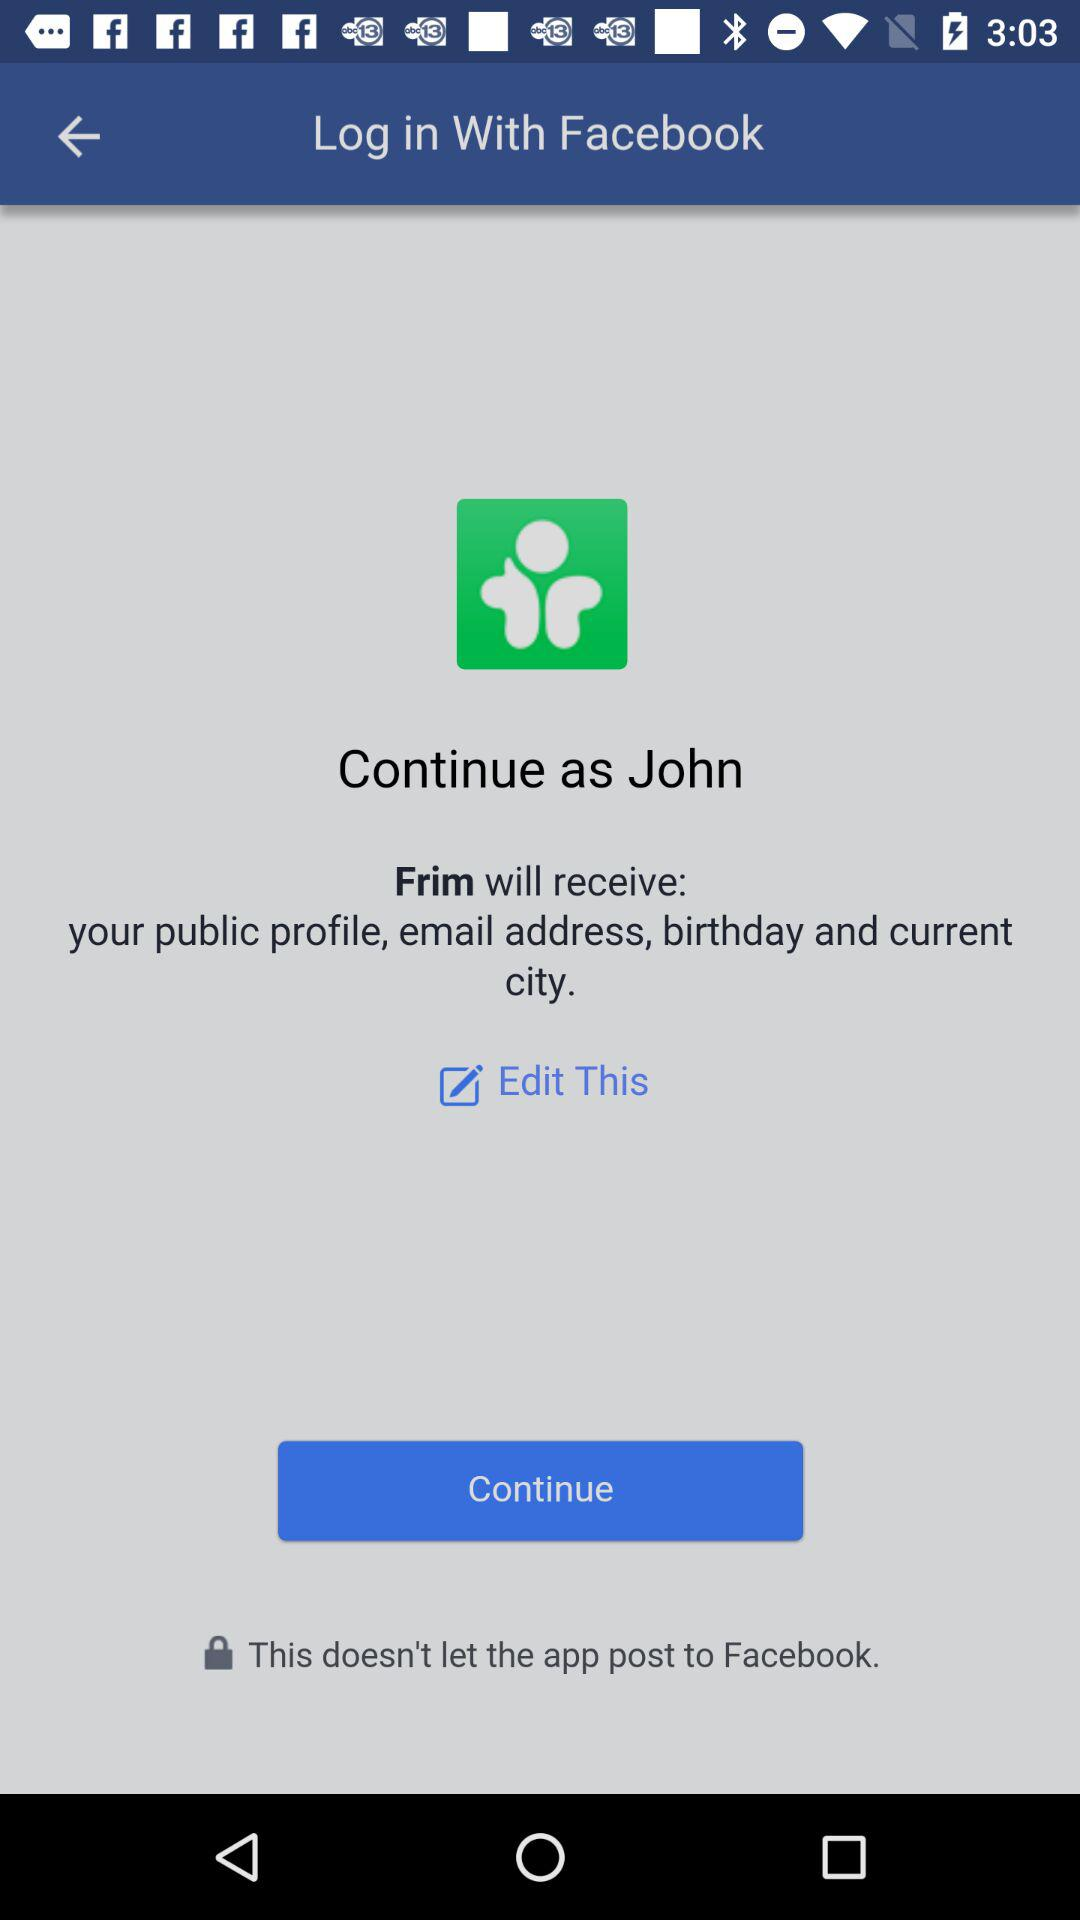What application is asking for permission? The application asking for permission is "Frim". 